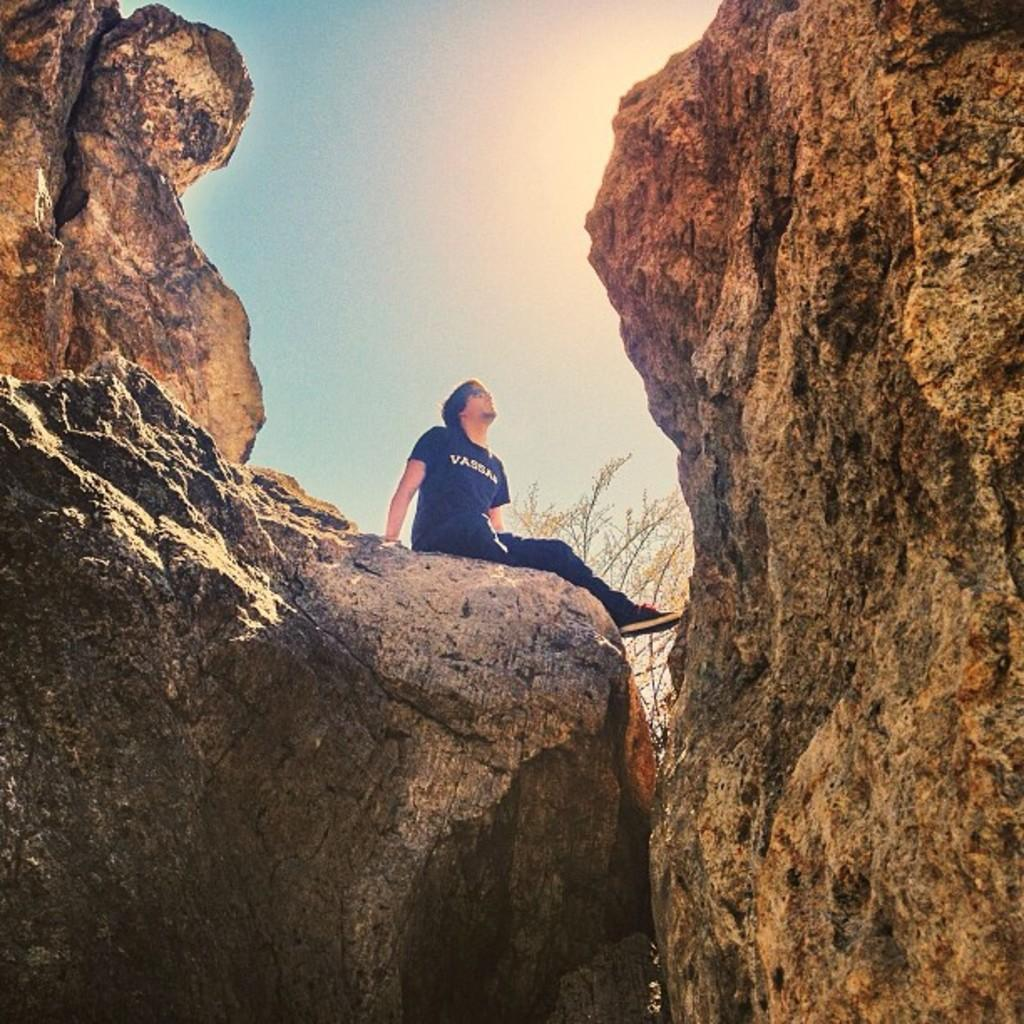What is the person in the image doing? There is a person sitting on a rock in the image. What can be seen on both sides of the image? There are hills on either side of the image. What is visible in the background of the image? The sky is visible in the background of the image. What type of pet can be seen licking a wound in the image? There is no pet or wound present in the image. 